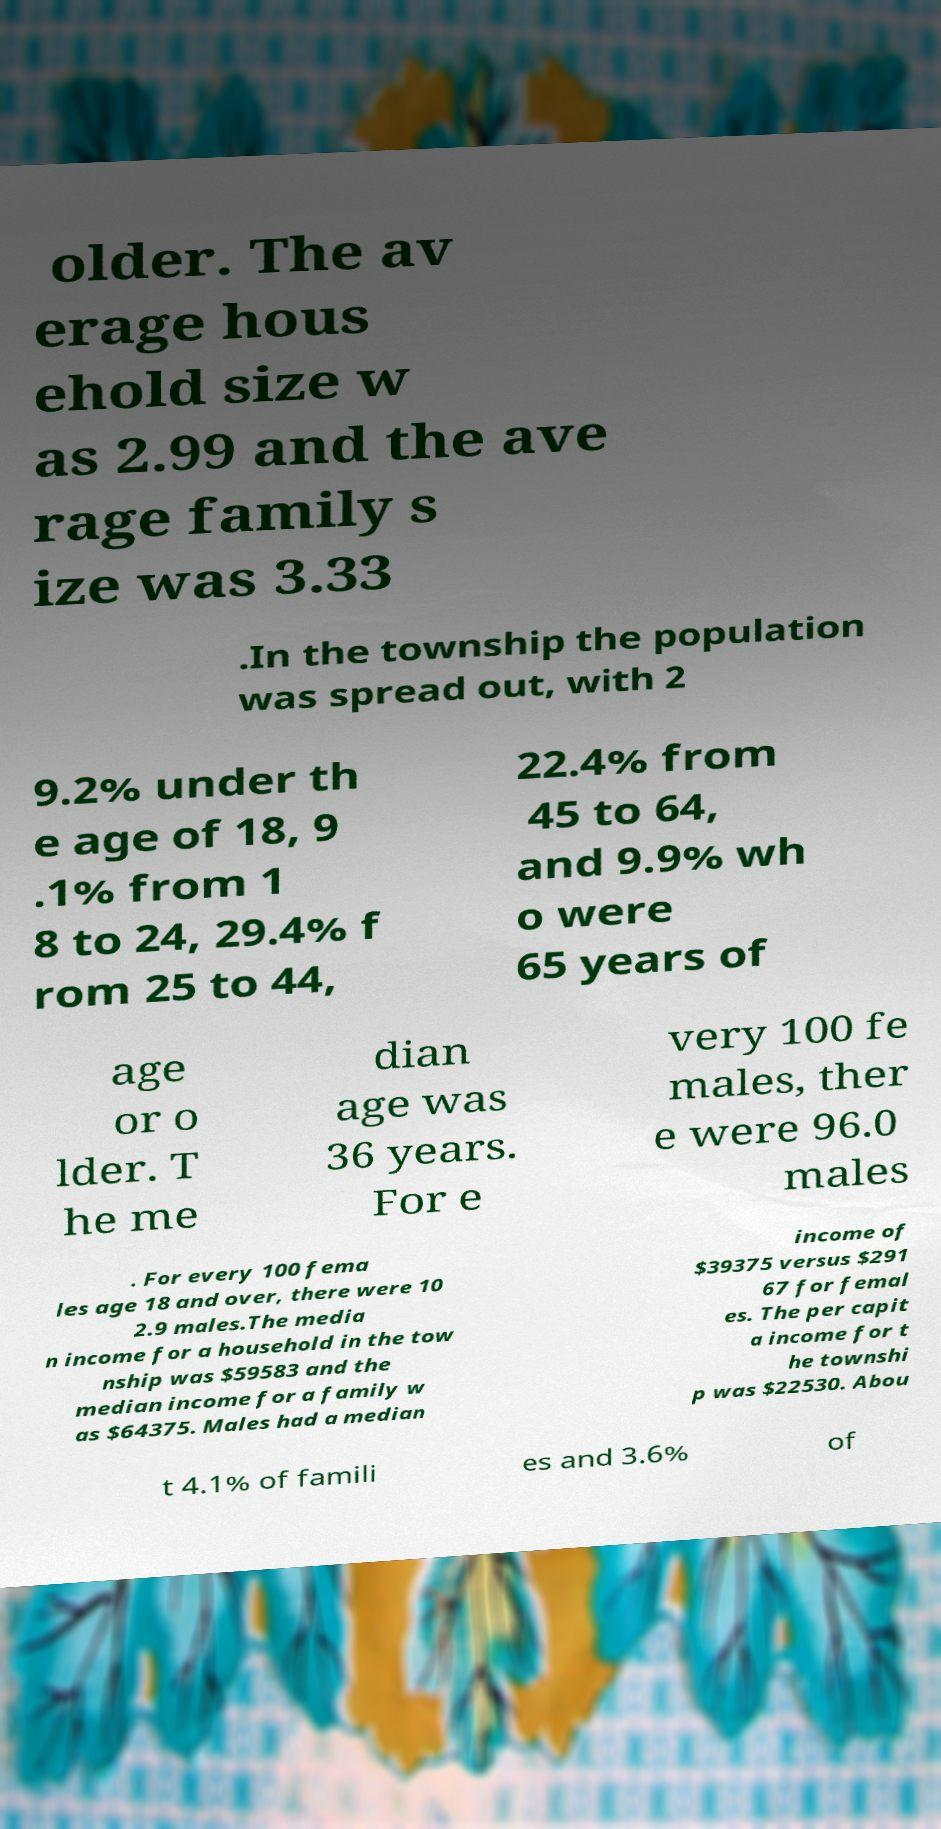Please read and relay the text visible in this image. What does it say? older. The av erage hous ehold size w as 2.99 and the ave rage family s ize was 3.33 .In the township the population was spread out, with 2 9.2% under th e age of 18, 9 .1% from 1 8 to 24, 29.4% f rom 25 to 44, 22.4% from 45 to 64, and 9.9% wh o were 65 years of age or o lder. T he me dian age was 36 years. For e very 100 fe males, ther e were 96.0 males . For every 100 fema les age 18 and over, there were 10 2.9 males.The media n income for a household in the tow nship was $59583 and the median income for a family w as $64375. Males had a median income of $39375 versus $291 67 for femal es. The per capit a income for t he townshi p was $22530. Abou t 4.1% of famili es and 3.6% of 